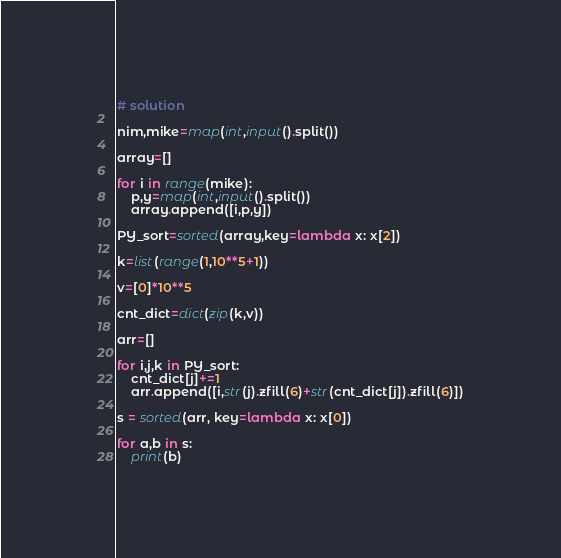Convert code to text. <code><loc_0><loc_0><loc_500><loc_500><_Python_># solution

nim,mike=map(int,input().split())

array=[]

for i in range(mike):
    p,y=map(int,input().split())
    array.append([i,p,y])

PY_sort=sorted(array,key=lambda x: x[2])

k=list(range(1,10**5+1))

v=[0]*10**5

cnt_dict=dict(zip(k,v))

arr=[]

for i,j,k in PY_sort:
    cnt_dict[j]+=1
    arr.append([i,str(j).zfill(6)+str(cnt_dict[j]).zfill(6)])

s = sorted(arr, key=lambda x: x[0])

for a,b in s:
    print(b)</code> 